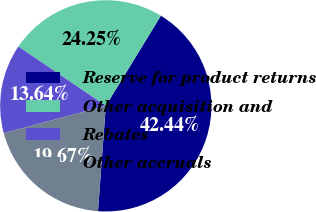<chart> <loc_0><loc_0><loc_500><loc_500><pie_chart><fcel>Reserve for product returns<fcel>Other acquisition and<fcel>Rebates<fcel>Other accruals<nl><fcel>42.44%<fcel>24.25%<fcel>13.64%<fcel>19.67%<nl></chart> 